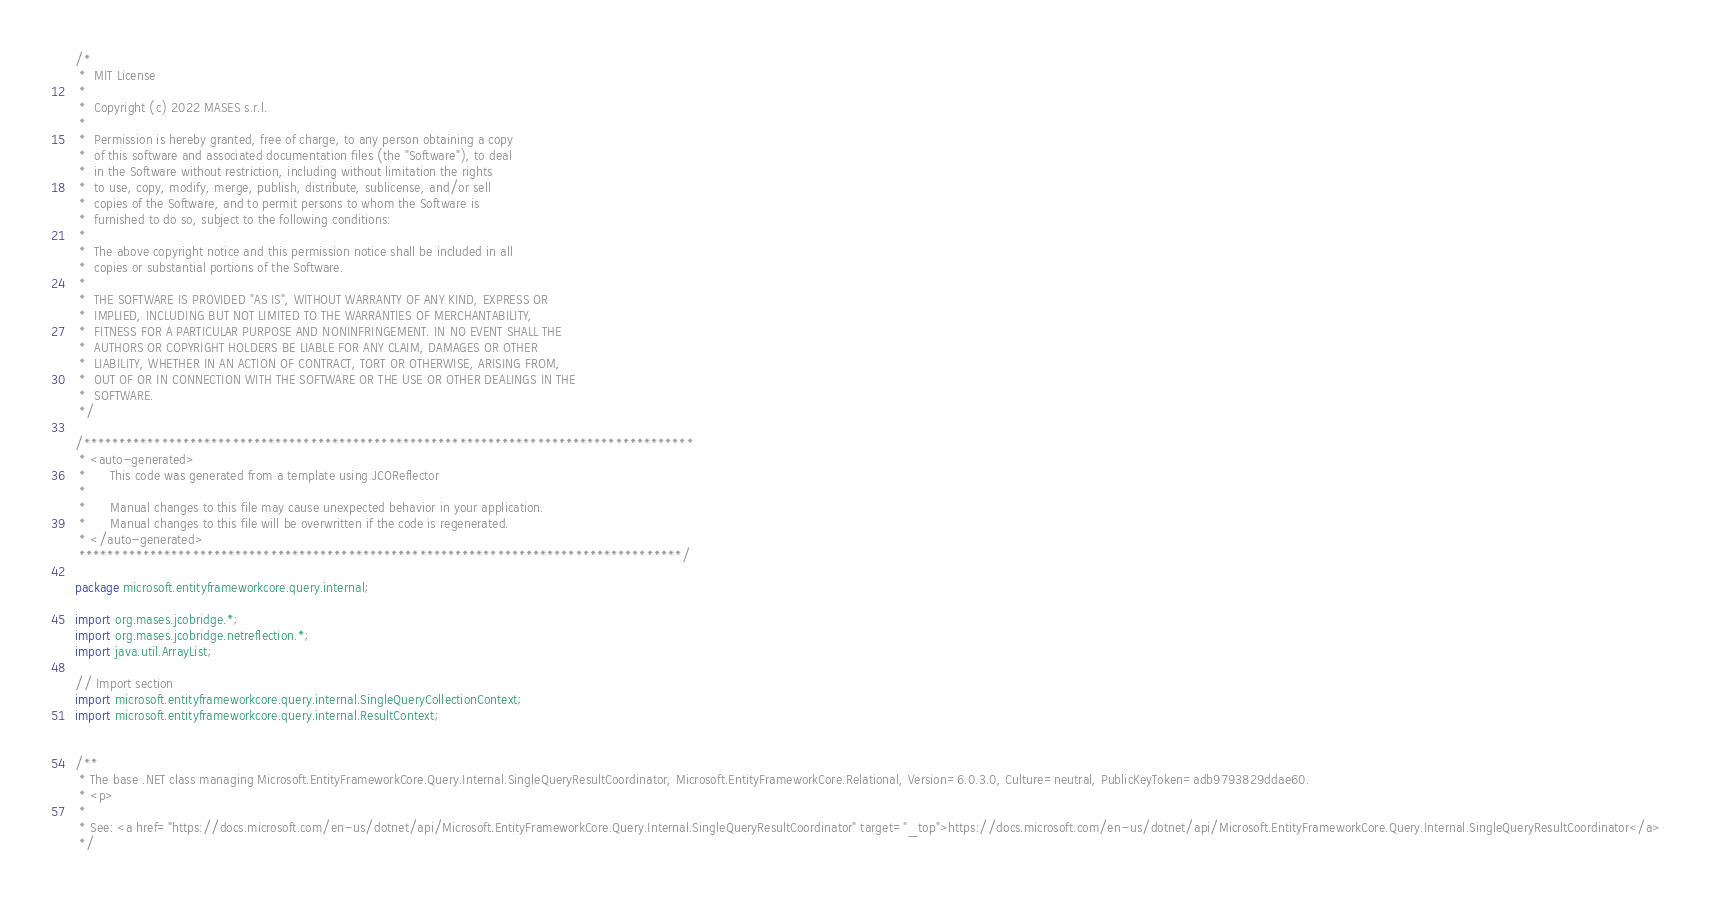<code> <loc_0><loc_0><loc_500><loc_500><_Java_>/*
 *  MIT License
 *
 *  Copyright (c) 2022 MASES s.r.l.
 *
 *  Permission is hereby granted, free of charge, to any person obtaining a copy
 *  of this software and associated documentation files (the "Software"), to deal
 *  in the Software without restriction, including without limitation the rights
 *  to use, copy, modify, merge, publish, distribute, sublicense, and/or sell
 *  copies of the Software, and to permit persons to whom the Software is
 *  furnished to do so, subject to the following conditions:
 *
 *  The above copyright notice and this permission notice shall be included in all
 *  copies or substantial portions of the Software.
 *
 *  THE SOFTWARE IS PROVIDED "AS IS", WITHOUT WARRANTY OF ANY KIND, EXPRESS OR
 *  IMPLIED, INCLUDING BUT NOT LIMITED TO THE WARRANTIES OF MERCHANTABILITY,
 *  FITNESS FOR A PARTICULAR PURPOSE AND NONINFRINGEMENT. IN NO EVENT SHALL THE
 *  AUTHORS OR COPYRIGHT HOLDERS BE LIABLE FOR ANY CLAIM, DAMAGES OR OTHER
 *  LIABILITY, WHETHER IN AN ACTION OF CONTRACT, TORT OR OTHERWISE, ARISING FROM,
 *  OUT OF OR IN CONNECTION WITH THE SOFTWARE OR THE USE OR OTHER DEALINGS IN THE
 *  SOFTWARE.
 */

/**************************************************************************************
 * <auto-generated>
 *      This code was generated from a template using JCOReflector
 * 
 *      Manual changes to this file may cause unexpected behavior in your application.
 *      Manual changes to this file will be overwritten if the code is regenerated.
 * </auto-generated>
 *************************************************************************************/

package microsoft.entityframeworkcore.query.internal;

import org.mases.jcobridge.*;
import org.mases.jcobridge.netreflection.*;
import java.util.ArrayList;

// Import section
import microsoft.entityframeworkcore.query.internal.SingleQueryCollectionContext;
import microsoft.entityframeworkcore.query.internal.ResultContext;


/**
 * The base .NET class managing Microsoft.EntityFrameworkCore.Query.Internal.SingleQueryResultCoordinator, Microsoft.EntityFrameworkCore.Relational, Version=6.0.3.0, Culture=neutral, PublicKeyToken=adb9793829ddae60.
 * <p>
 * 
 * See: <a href="https://docs.microsoft.com/en-us/dotnet/api/Microsoft.EntityFrameworkCore.Query.Internal.SingleQueryResultCoordinator" target="_top">https://docs.microsoft.com/en-us/dotnet/api/Microsoft.EntityFrameworkCore.Query.Internal.SingleQueryResultCoordinator</a>
 */</code> 